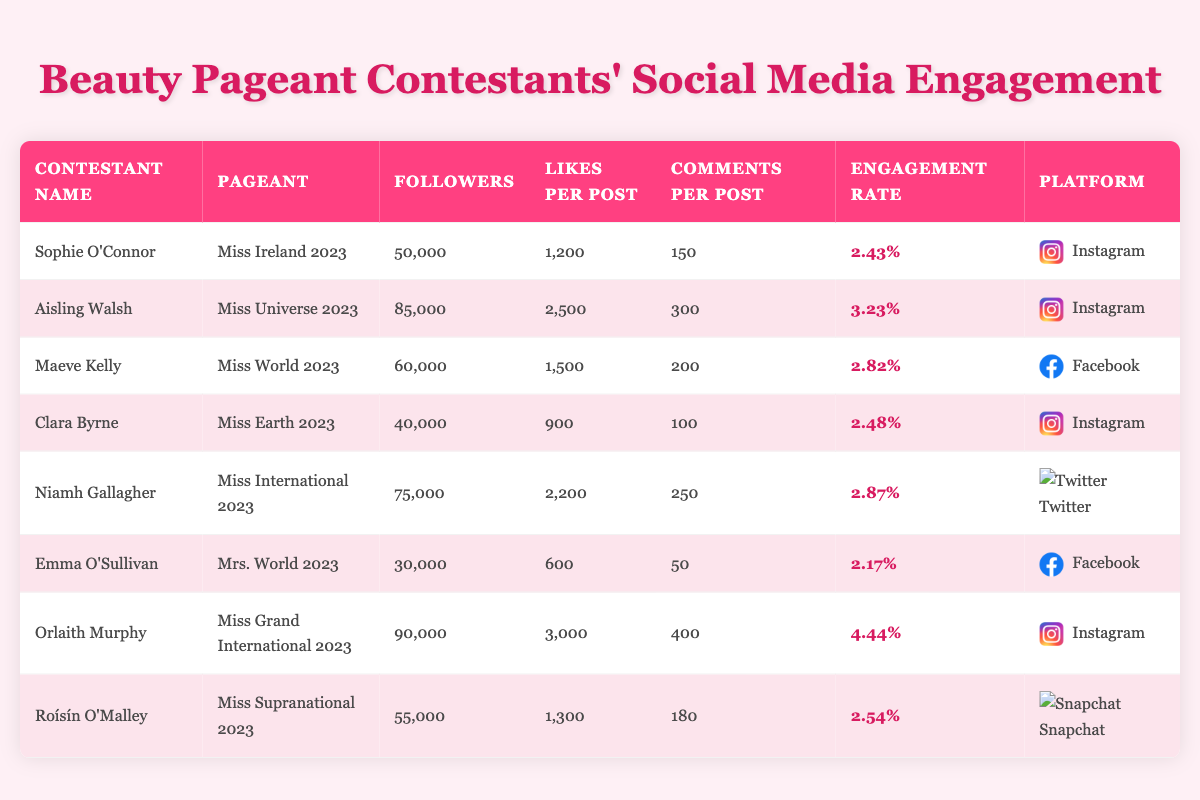What is the highest engagement rate among the contestants? The highest engagement rate in the table is found by comparing the engagement rates listed in the last column. The maximum value is 4.44%, which is for Orlaith Murphy.
Answer: 4.44% Which contestant has the most followers? To find the contestant with the most followers, I compared the numbers in the 'Followers' column. The maximum is 90,000, which belongs to Orlaith Murphy.
Answer: Orlaith Murphy What is the average number of likes per post among all contestants? To calculate the average likes per post, I first sum the likes per post: (1200 + 2500 + 1500 + 900 + 2200 + 600 + 3000 + 1300) = 10,200. Then, I divide by the number of contestants, which is 8: 10,200 / 8 = 1,275.
Answer: 1,275 Do any contestants have an engagement rate above 3%? By reviewing the engagement rates in the relevant column, I see that Aisling Walsh (3.23%) and Orlaith Murphy (4.44%) both have rates above 3%. Thus, the answer is yes.
Answer: Yes What is the difference in engagement rates between the contestants with the highest and lowest engagement rates? The highest engagement rate is 4.44% (Orlaith Murphy) and the lowest is 2.17% (Emma O'Sullivan). The difference is calculated as 4.44% - 2.17% = 2.27%.
Answer: 2.27% Which platform has the most contestants using it in the table? I need to count the number of contestants associated with each platform listed. Instagram has 4 contestants, Facebook has 2, Twitter has 1, and Snapchat has 1. Thus, Instagram is the platform with the most contestants.
Answer: Instagram Is Maeve Kelly's engagement rate higher than that of Sophie O'Connor? Maeve Kelly's engagement rate is 2.82% and Sophie O'Connor's is 2.43%. Since 2.82% is greater than 2.43%, the answer is yes.
Answer: Yes Who is the contestant with the least number of comments per post? I check the 'Comments per Post' column for the minimum value. The lowest is 50 comments per post, related to Emma O'Sullivan.
Answer: Emma O'Sullivan 